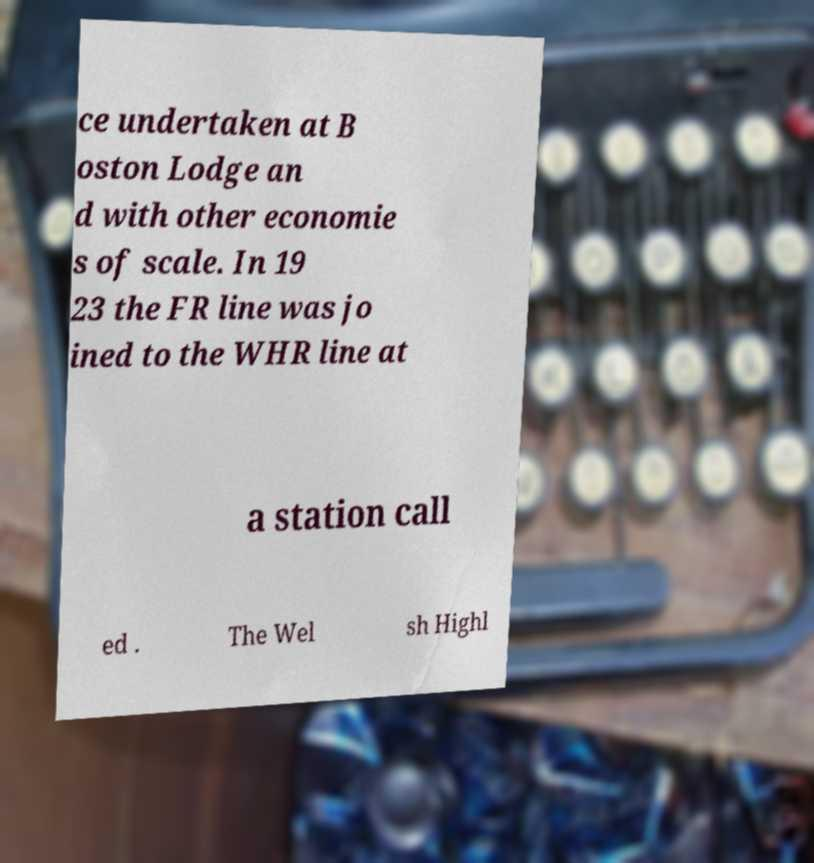Can you read and provide the text displayed in the image?This photo seems to have some interesting text. Can you extract and type it out for me? ce undertaken at B oston Lodge an d with other economie s of scale. In 19 23 the FR line was jo ined to the WHR line at a station call ed . The Wel sh Highl 